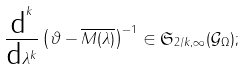Convert formula to latex. <formula><loc_0><loc_0><loc_500><loc_500>\frac { \text {d} ^ { k } } { \text {d} \lambda ^ { k } } \left ( \vartheta - \overline { M ( \lambda ) } \right ) ^ { - 1 } \in \mathfrak { S } _ { 2 / k , \infty } ( \mathcal { G } _ { \Omega } ) ;</formula> 